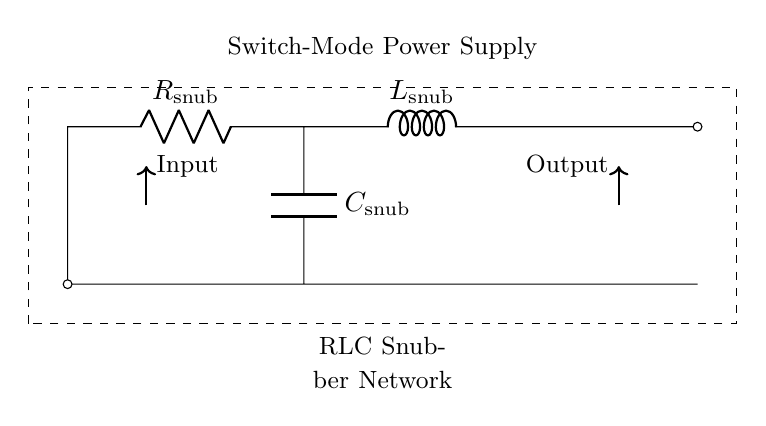What is the component type at the top of the circuit? The component located at the top of the circuit is a resistor, as indicated by the symbols and labels in the diagram.
Answer: resistor What does the 'R' label stand for? The 'R' label denotes a resistor, which is used for limiting current and controlling voltage in the circuit.
Answer: resistor How many components are present in the snubber network? There are three components in the snubber network: one resistor, one inductor, and one capacitor, as shown in the circuit diagram.
Answer: three What is the purpose of this RLC circuit? The RLC circuit's purpose is to suppress voltage spikes, which can occur in switch-mode power supplies, protecting other components from damage.
Answer: suppress voltage spikes What is the value of the capacitor in this circuit? The capacitor is labeled as 'C_snub', indicating it is the snubber capacitor, but the exact numeric value is not specified in the visual circuit diagram.
Answer: C_snub Why is the inductor placed in series with the resistor and capacitor? The inductor is placed in series to create a time delay and dampen oscillations, which helps control voltage spikes during switching events in the power supply.
Answer: dampen oscillations What type of circuit is this? This is an RLC snubber network, which is a specific type of circuit that utilizes resistors, inductors, and capacitors for voltage spike suppression.
Answer: RLC snubber network 